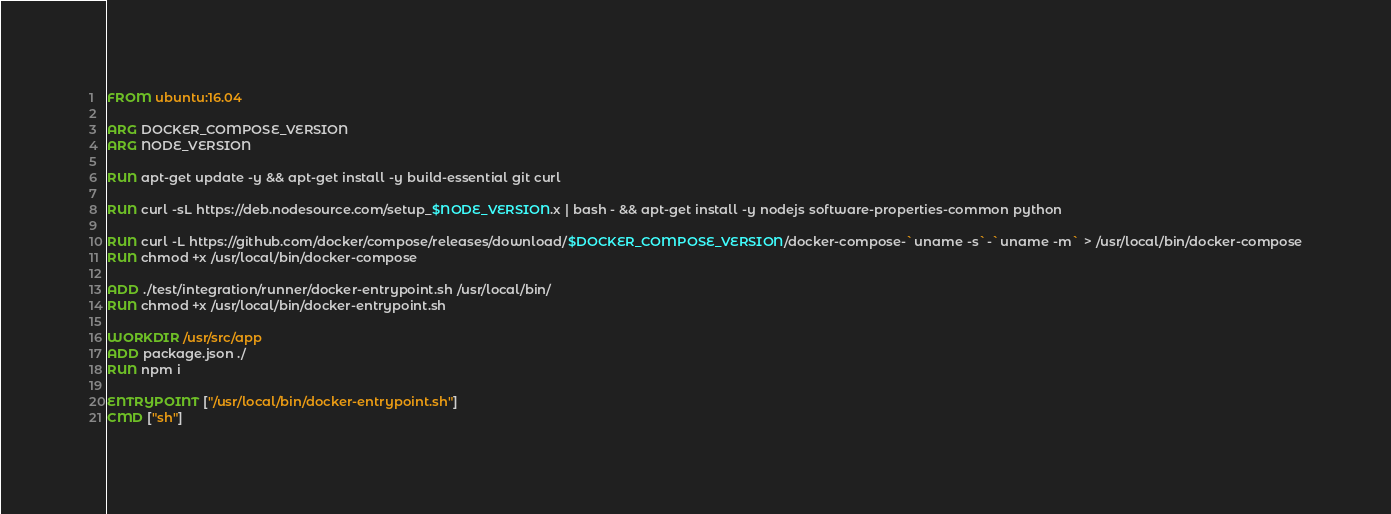Convert code to text. <code><loc_0><loc_0><loc_500><loc_500><_Dockerfile_>FROM ubuntu:16.04

ARG DOCKER_COMPOSE_VERSION
ARG NODE_VERSION

RUN apt-get update -y && apt-get install -y build-essential git curl

RUN curl -sL https://deb.nodesource.com/setup_$NODE_VERSION.x | bash - && apt-get install -y nodejs software-properties-common python

RUN curl -L https://github.com/docker/compose/releases/download/$DOCKER_COMPOSE_VERSION/docker-compose-`uname -s`-`uname -m` > /usr/local/bin/docker-compose
RUN chmod +x /usr/local/bin/docker-compose

ADD ./test/integration/runner/docker-entrypoint.sh /usr/local/bin/
RUN chmod +x /usr/local/bin/docker-entrypoint.sh

WORKDIR /usr/src/app
ADD package.json ./
RUN npm i

ENTRYPOINT ["/usr/local/bin/docker-entrypoint.sh"]
CMD ["sh"]
</code> 